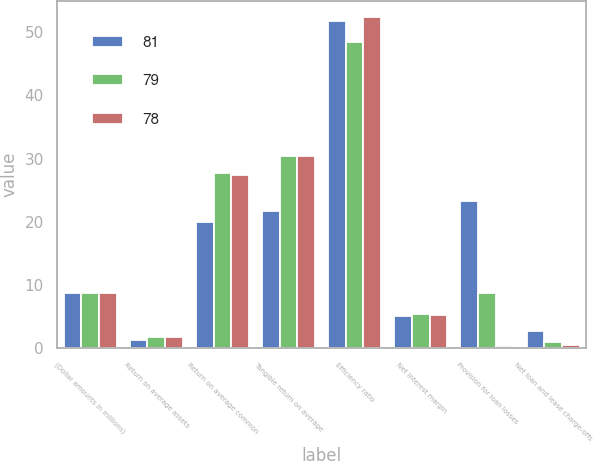<chart> <loc_0><loc_0><loc_500><loc_500><stacked_bar_chart><ecel><fcel>(Dollar amounts in millions)<fcel>Return on average assets<fcel>Return on average common<fcel>Tangible return on average<fcel>Efficiency ratio<fcel>Net interest margin<fcel>Provision for loan losses<fcel>Net loan and lease charge-offs<nl><fcel>81<fcel>8.7<fcel>1.35<fcel>19.9<fcel>21.7<fcel>51.82<fcel>5.06<fcel>23.3<fcel>2.7<nl><fcel>79<fcel>8.7<fcel>1.82<fcel>27.68<fcel>30.35<fcel>48.37<fcel>5.46<fcel>8.7<fcel>1<nl><fcel>78<fcel>8.7<fcel>1.78<fcel>27.35<fcel>30.39<fcel>52.37<fcel>5.26<fcel>0.4<fcel>0.5<nl></chart> 